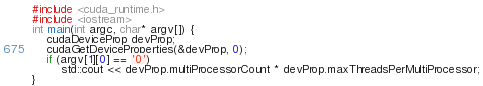Convert code to text. <code><loc_0><loc_0><loc_500><loc_500><_Cuda_>#include <cuda_runtime.h>
#include <iostream>
int main(int argc, char* argv[]) {
	cudaDeviceProp devProp;
	cudaGetDeviceProperties(&devProp, 0);
	if (argv[1][0] == '0')
		std::cout << devProp.multiProcessorCount * devProp.maxThreadsPerMultiProcessor;
}
</code> 